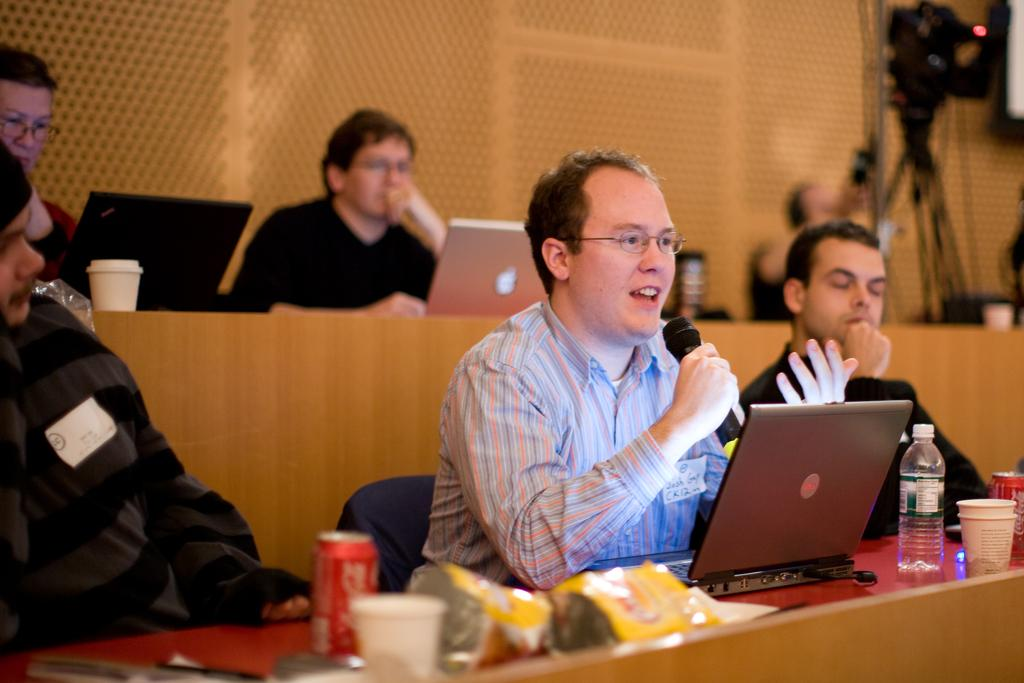What are the people in the image doing? The people in the image are sitting on chairs. What is the person at the center doing? The person at the center is speaking. What is the person at the center holding? The person at the center is holding a microphone. What is in front of the person at the center? There is a laptop, a glass, and a bottle in front of the person at the center. How many passengers are visible in the image? There are no passengers visible in the image; it features people sitting on chairs. Is there a jail in the background of the image? There is no jail present in the image. 